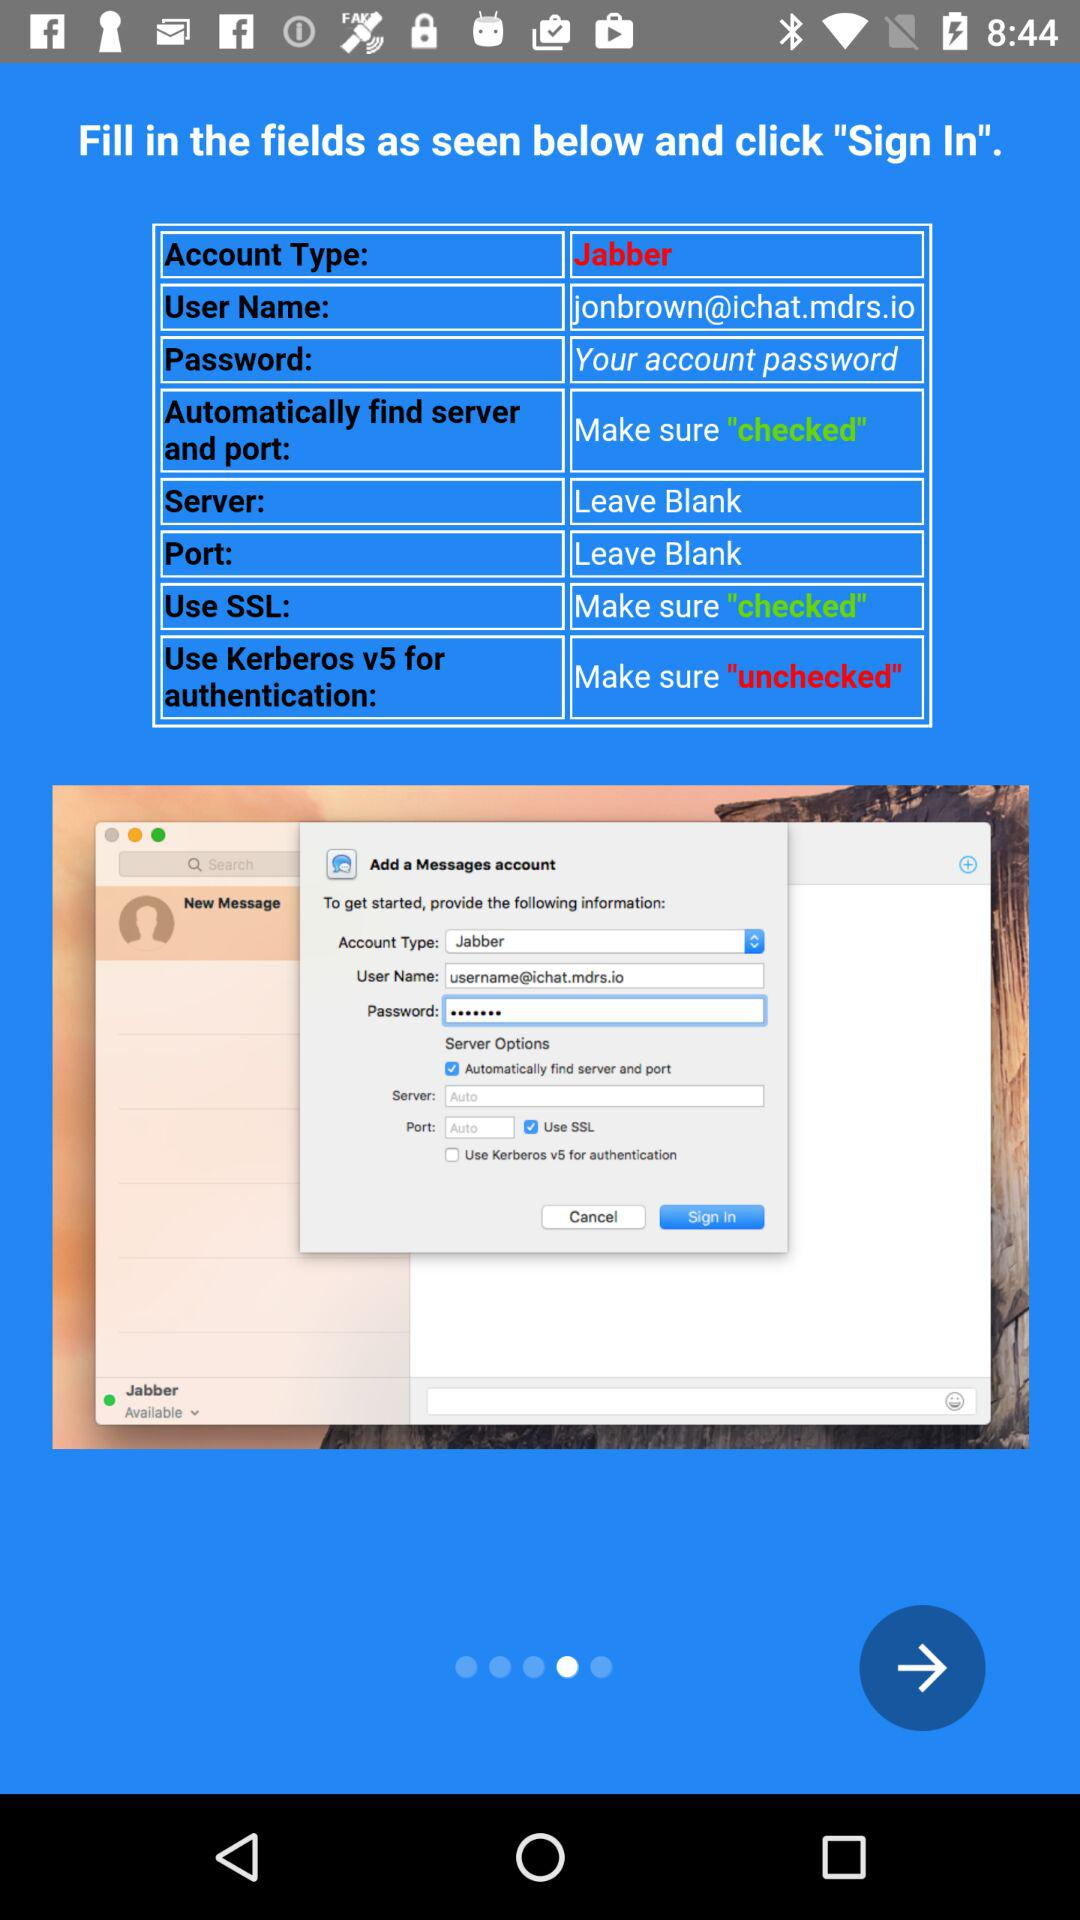What is the user name? The user name is jonbrown@ichat.mdrs.io. 